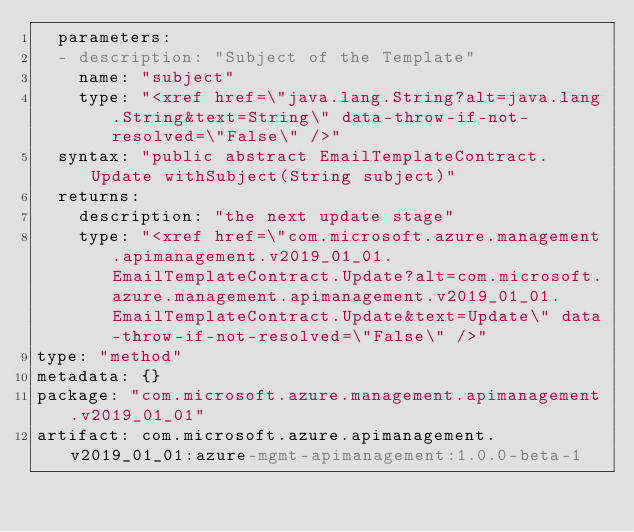Convert code to text. <code><loc_0><loc_0><loc_500><loc_500><_YAML_>  parameters:
  - description: "Subject of the Template"
    name: "subject"
    type: "<xref href=\"java.lang.String?alt=java.lang.String&text=String\" data-throw-if-not-resolved=\"False\" />"
  syntax: "public abstract EmailTemplateContract.Update withSubject(String subject)"
  returns:
    description: "the next update stage"
    type: "<xref href=\"com.microsoft.azure.management.apimanagement.v2019_01_01.EmailTemplateContract.Update?alt=com.microsoft.azure.management.apimanagement.v2019_01_01.EmailTemplateContract.Update&text=Update\" data-throw-if-not-resolved=\"False\" />"
type: "method"
metadata: {}
package: "com.microsoft.azure.management.apimanagement.v2019_01_01"
artifact: com.microsoft.azure.apimanagement.v2019_01_01:azure-mgmt-apimanagement:1.0.0-beta-1
</code> 